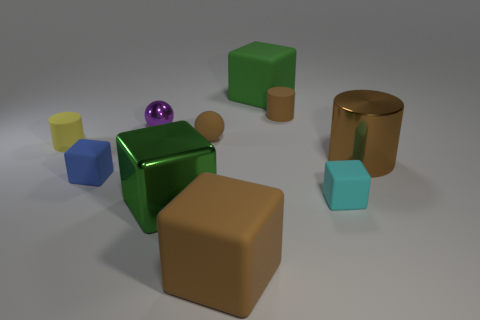Do the large cylinder and the rubber ball have the same color?
Your answer should be compact. Yes. Are there more big things that are behind the rubber ball than yellow cylinders that are in front of the cyan object?
Make the answer very short. Yes. Are there any big shiny objects of the same shape as the yellow rubber thing?
Provide a short and direct response. Yes. There is a rubber cylinder right of the purple metallic sphere; does it have the same size as the tiny yellow rubber thing?
Offer a very short reply. Yes. Are there any large purple matte cubes?
Keep it short and to the point. No. How many things are either large matte cubes that are in front of the brown rubber cylinder or tiny green metal things?
Give a very brief answer. 1. Is the color of the metal cylinder the same as the matte cylinder that is right of the purple shiny thing?
Your answer should be very brief. Yes. Is there a gray rubber ball of the same size as the cyan cube?
Your answer should be compact. No. What material is the small cylinder on the left side of the big matte block right of the large brown matte object?
Make the answer very short. Rubber. What number of big things are the same color as the metal cylinder?
Offer a very short reply. 1. 